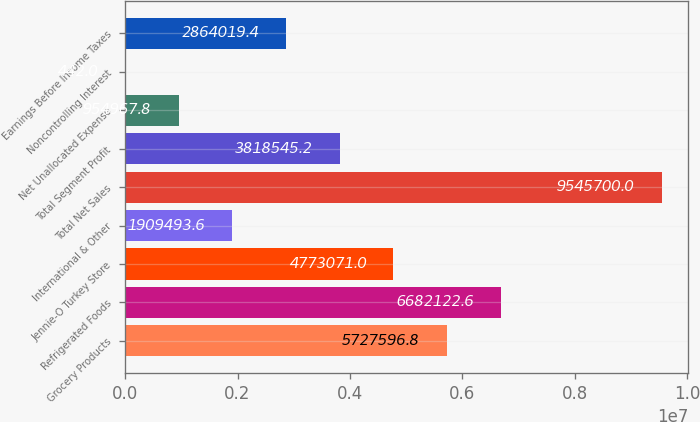Convert chart to OTSL. <chart><loc_0><loc_0><loc_500><loc_500><bar_chart><fcel>Grocery Products<fcel>Refrigerated Foods<fcel>Jennie-O Turkey Store<fcel>International & Other<fcel>Total Net Sales<fcel>Total Segment Profit<fcel>Net Unallocated Expense<fcel>Noncontrolling Interest<fcel>Earnings Before Income Taxes<nl><fcel>5.7276e+06<fcel>6.68212e+06<fcel>4.77307e+06<fcel>1.90949e+06<fcel>9.5457e+06<fcel>3.81855e+06<fcel>954968<fcel>442<fcel>2.86402e+06<nl></chart> 